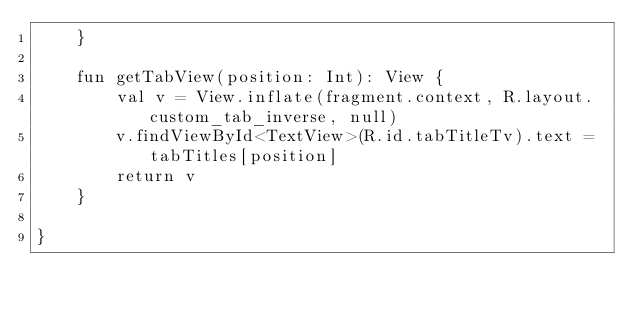Convert code to text. <code><loc_0><loc_0><loc_500><loc_500><_Kotlin_>    }

    fun getTabView(position: Int): View {
        val v = View.inflate(fragment.context, R.layout.custom_tab_inverse, null)
        v.findViewById<TextView>(R.id.tabTitleTv).text = tabTitles[position]
        return v
    }

}</code> 